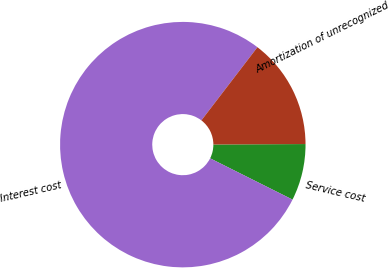<chart> <loc_0><loc_0><loc_500><loc_500><pie_chart><fcel>Service cost<fcel>Interest cost<fcel>Amortization of unrecognized<nl><fcel>7.47%<fcel>78.01%<fcel>14.52%<nl></chart> 